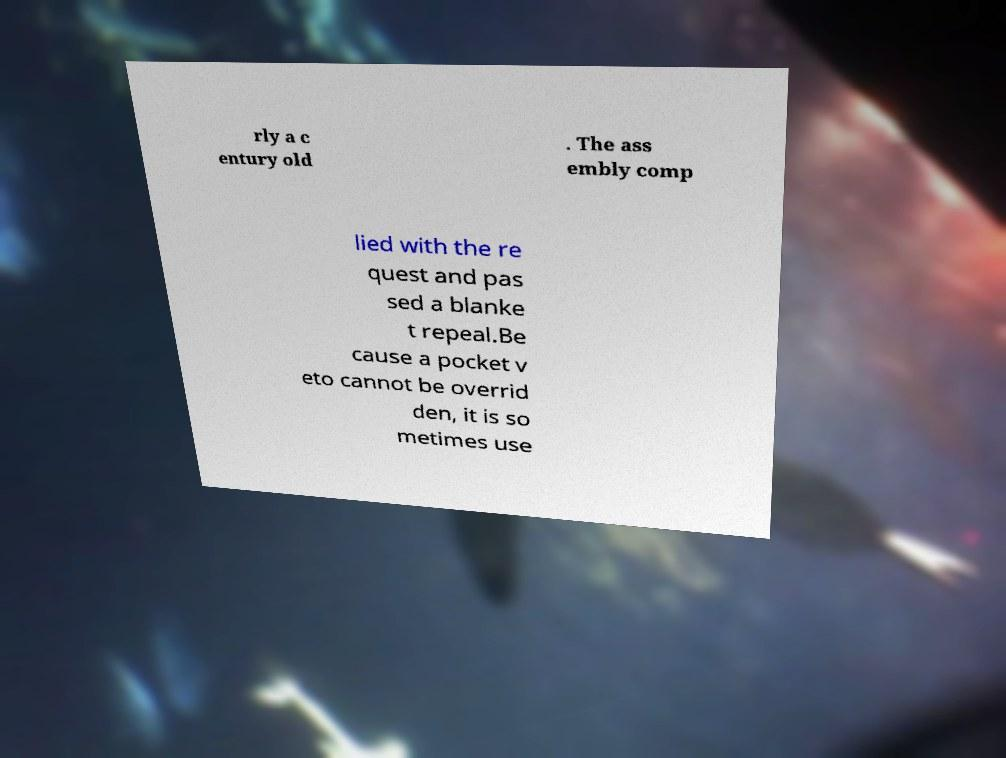For documentation purposes, I need the text within this image transcribed. Could you provide that? rly a c entury old . The ass embly comp lied with the re quest and pas sed a blanke t repeal.Be cause a pocket v eto cannot be overrid den, it is so metimes use 